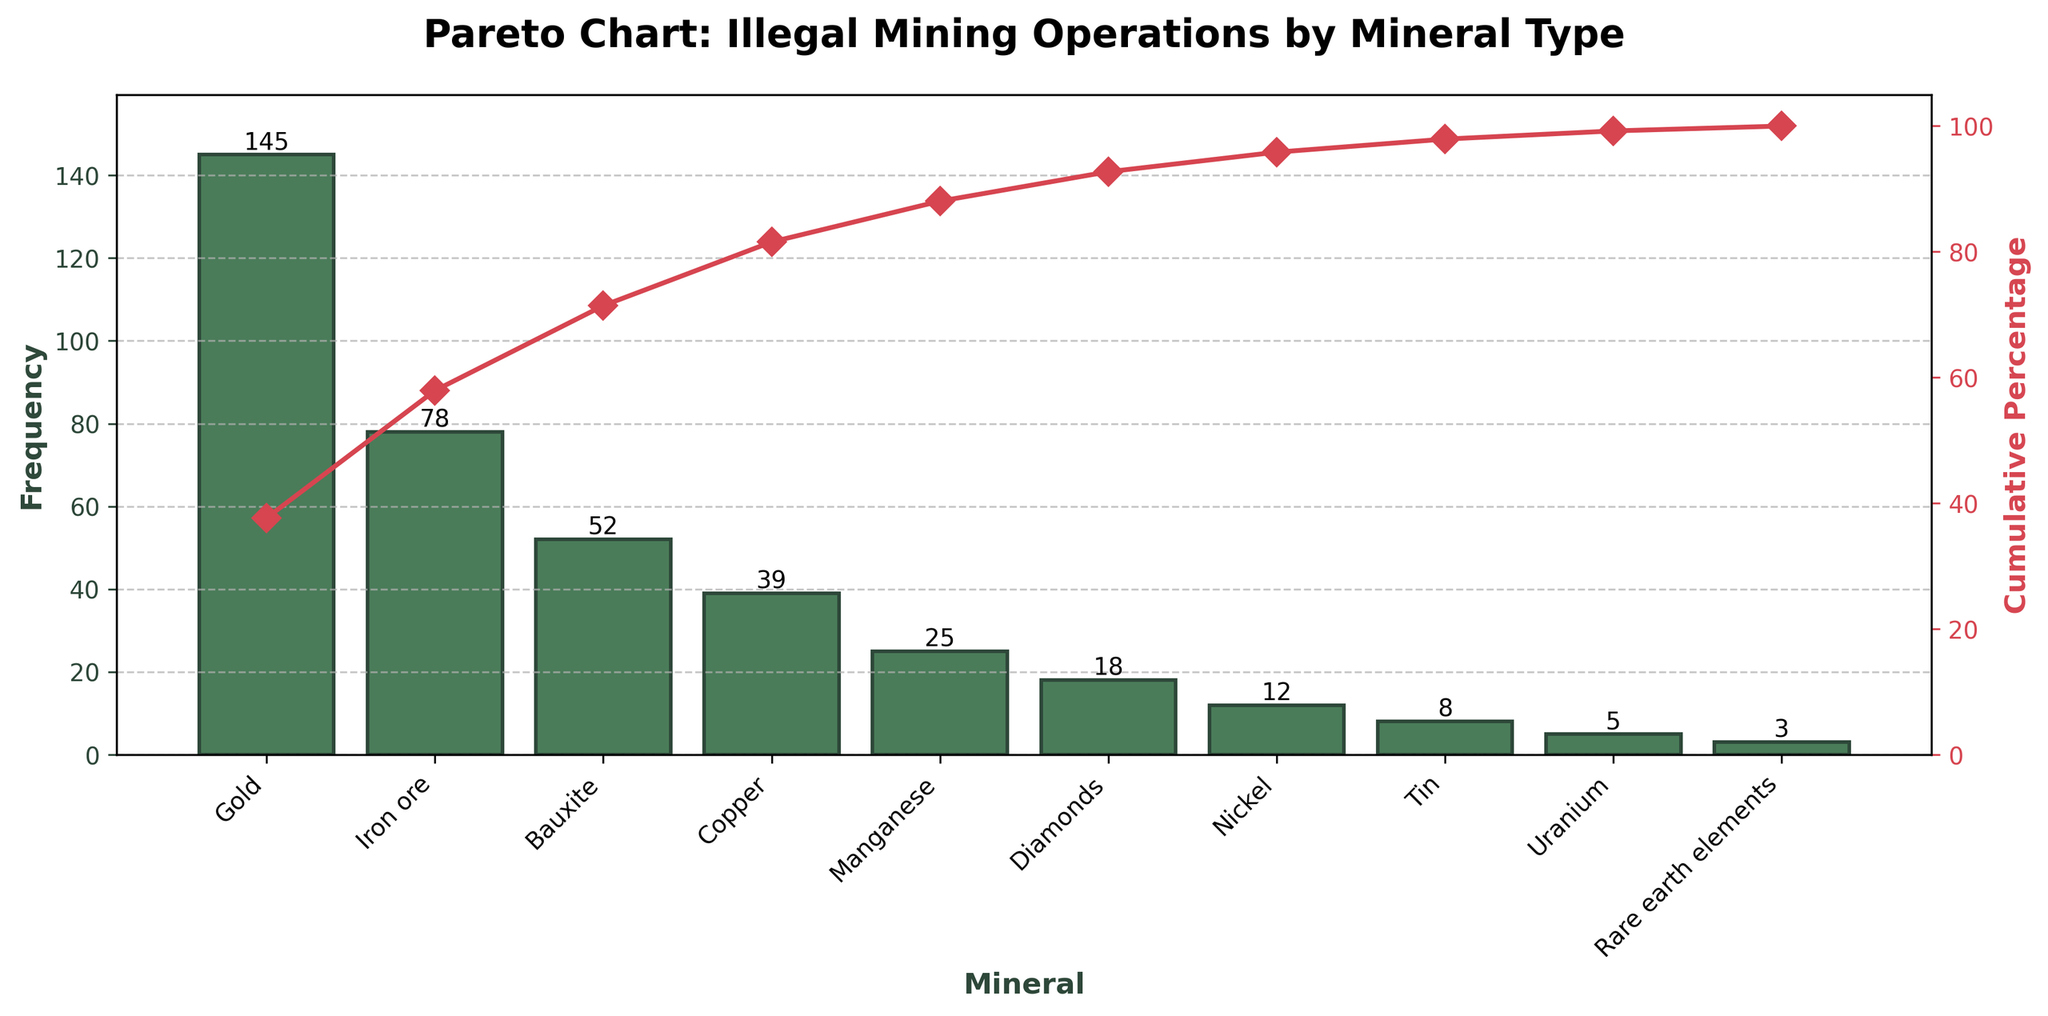How many minerals are listed in the chart? The x-axis displays the different mineral types used in illegal mining operations. By counting the labels on the x-axis, one can determine the number of minerals listed.
Answer: 10 Which mineral has the highest frequency of illegal mining operations? The mineral with the highest bar corresponds to the highest frequency. From the chart, this is the first (and tallest) bar on the left.
Answer: Gold What is the cumulative percentage for Bauxite? Locate Bauxite on the x-axis and then follow up to where the cumulative line intersects above it. The corresponding value on the right y-axis is the cumulative percentage for Bauxite.
Answer: 73.63% How does the frequency of mining Gold compare to Diamonds? Identify the heights of the bars for Gold and Diamonds. The bar for Gold is much higher than that for Diamonds, indicating a higher frequency of illegal mining operations for Gold.
Answer: Gold is mined more frequently What percentage of the total illegal mining operations is accounted for by the top three minerals? The cumulative percentage for the first three minerals (Gold, Iron ore, and Bauxite) as indicated by the line chart. This can be directly read from the cumulative percentage axis.
Answer: 79.45% How many mineral types constitute approximately 80% of the total illegal mining frequency? Look along the cumulative percentage line and find where it reaches closest to 80%. Count the number of minerals up to this point.
Answer: 3 minerals What is the difference in frequency between Nickel and Tin? Determine the heights of the bars for Nickel and Tin. Subtract the smaller value from the larger value.
Answer: 4 Which mineral has the lowest frequency of illegal mining operations, and what is that frequency? The shortest bar corresponds to the mineral with the lowest frequency. The corresponding label on the x-axis and the height of the bar give the mineral and its frequency.
Answer: Rare earth elements, 3 What is the cumulative percentage after including Uranium? Find Uranium on the x-axis and then follow up to where the cumulative line intersects above it. The corresponding value on the right y-axis is the cumulative percentage including Uranium.
Answer: 97.75% What is the average frequency of the illegal mining operations for all the minerals listed? Sum the frequencies of all mineral types and then divide by the total number of minerals to find the average. This involves adding up the given frequencies, then dividing by 10.
Answer: 38.5 